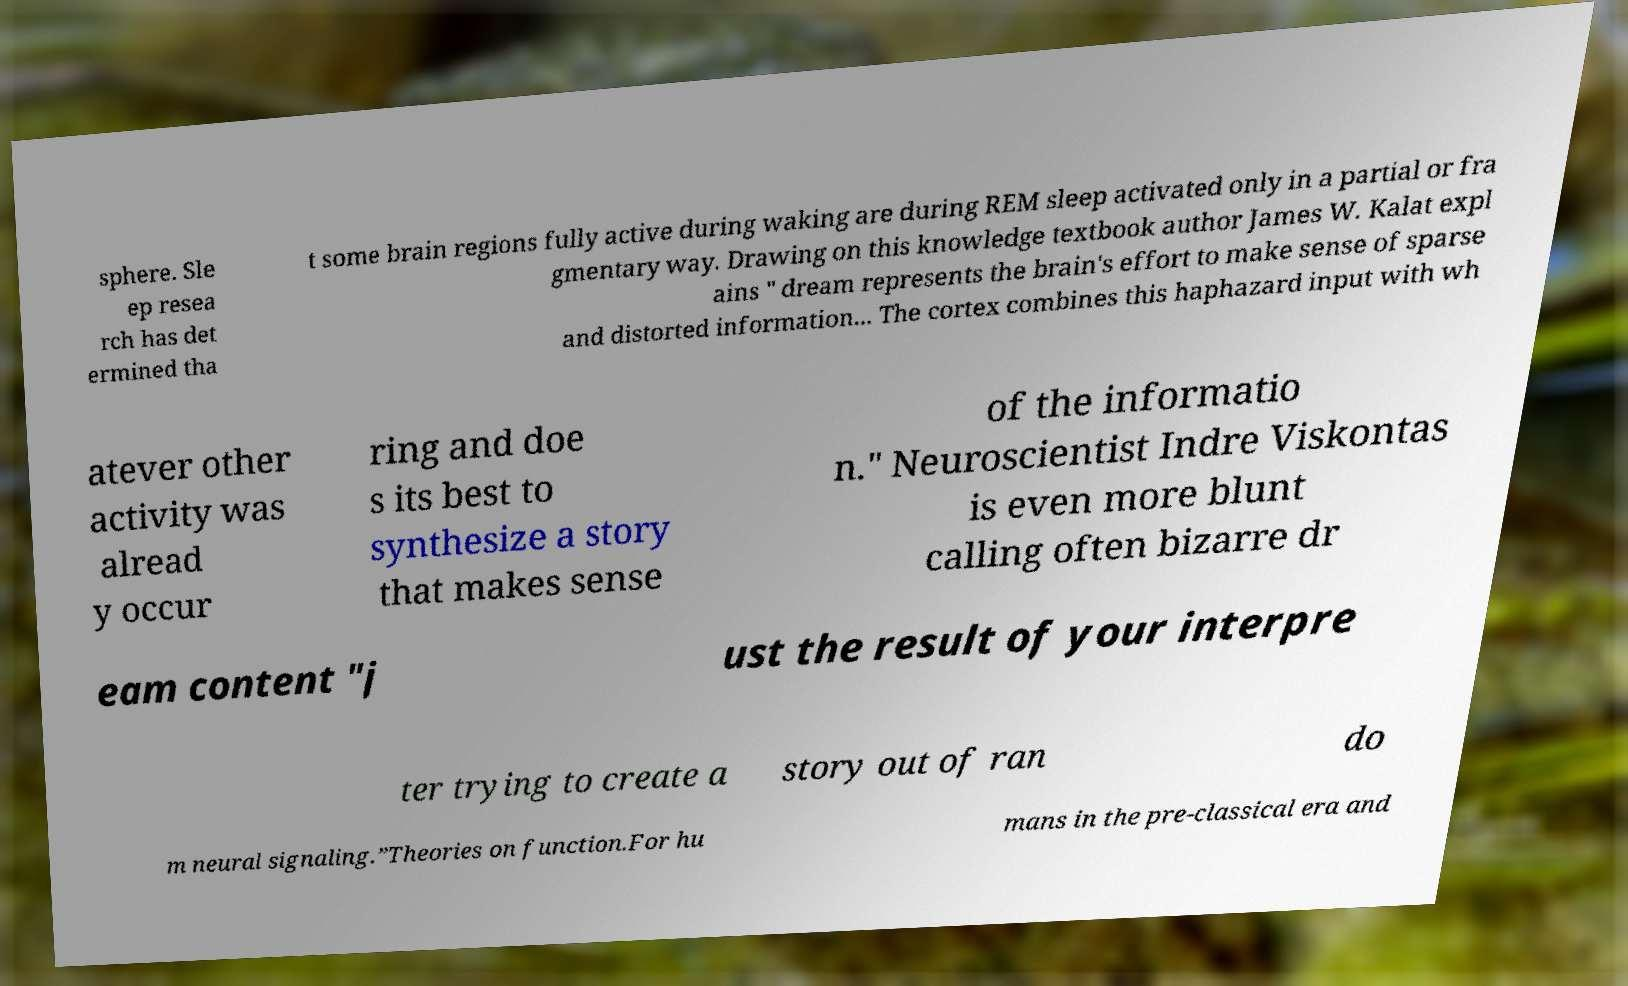What messages or text are displayed in this image? I need them in a readable, typed format. sphere. Sle ep resea rch has det ermined tha t some brain regions fully active during waking are during REM sleep activated only in a partial or fra gmentary way. Drawing on this knowledge textbook author James W. Kalat expl ains " dream represents the brain's effort to make sense of sparse and distorted information... The cortex combines this haphazard input with wh atever other activity was alread y occur ring and doe s its best to synthesize a story that makes sense of the informatio n." Neuroscientist Indre Viskontas is even more blunt calling often bizarre dr eam content "j ust the result of your interpre ter trying to create a story out of ran do m neural signaling.”Theories on function.For hu mans in the pre-classical era and 